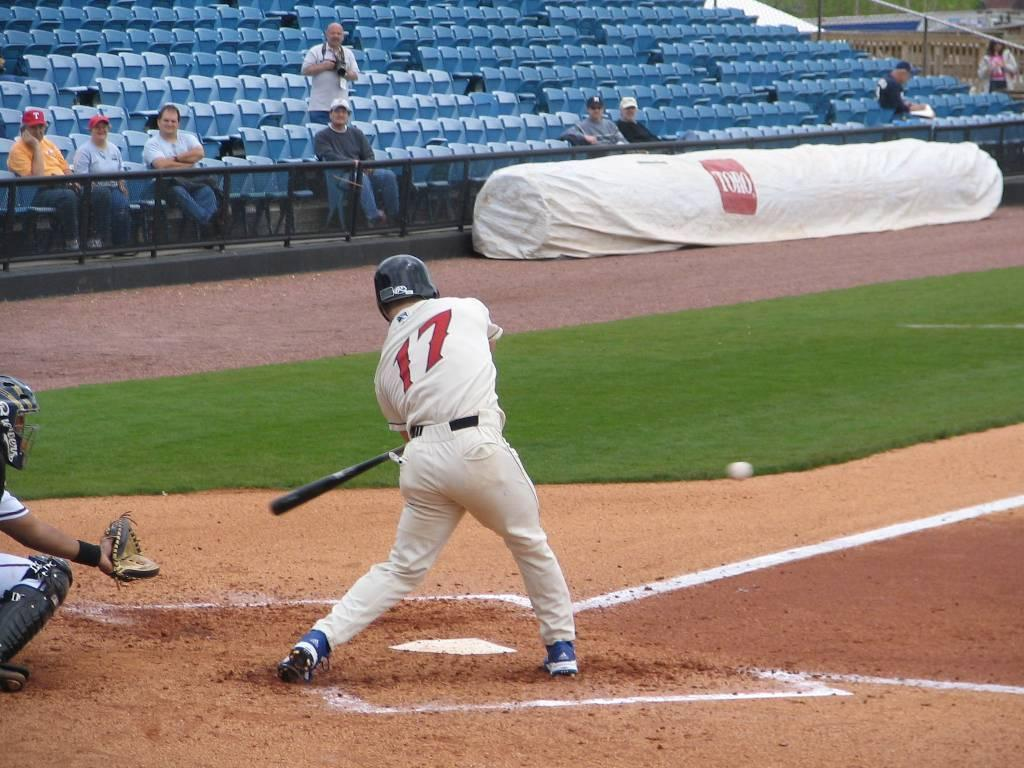<image>
Give a short and clear explanation of the subsequent image. baseball player getting ready to the the ball, he is # 17, and the sponsored logo on the back is Toro. 